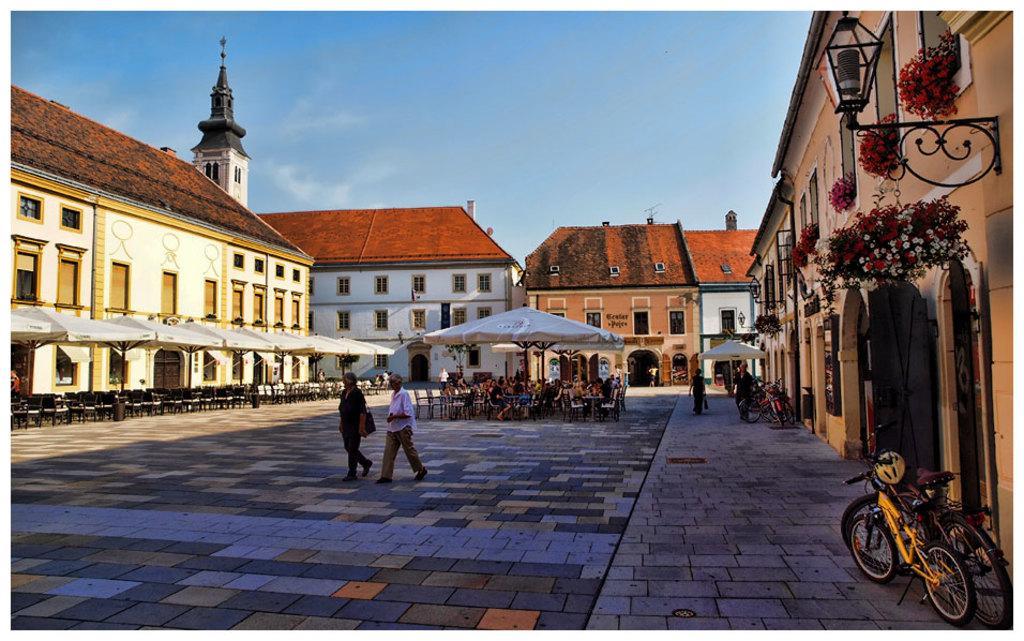Could you give a brief overview of what you see in this image? This picture shows few buildings and few tents with chairs and tables and few people are seated and few are walking and we see few bicycles parked on the sidewalk and we see plants with flowers and couple of lights and a blue cloudy Sky. 